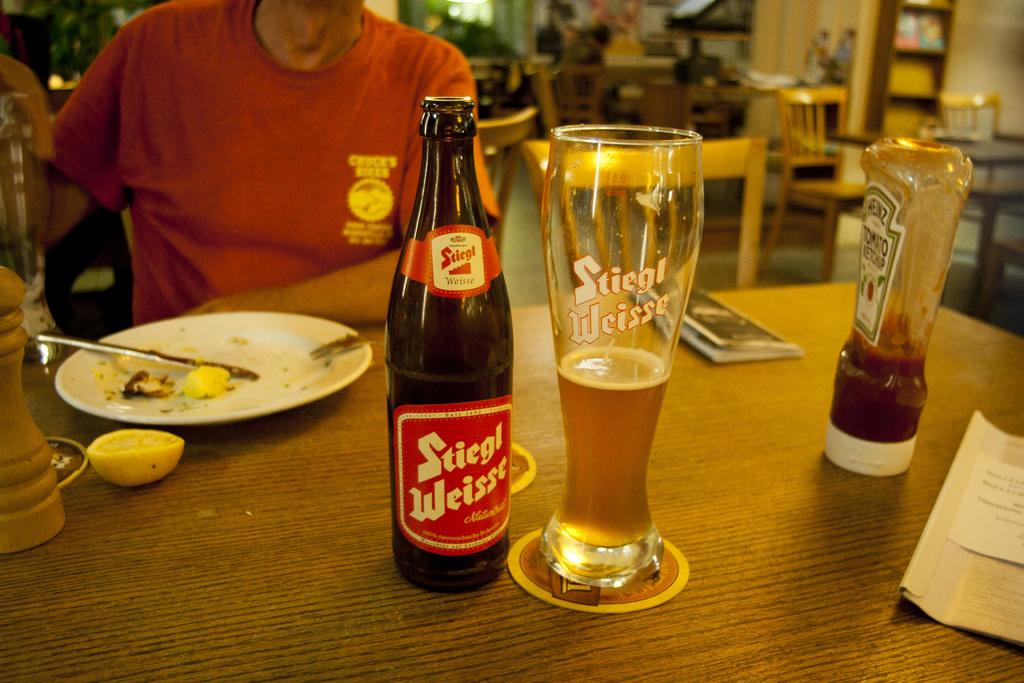Provide a one-sentence caption for the provided image. A bottle with Stiegl brand is sitting next to a glass on a table. 